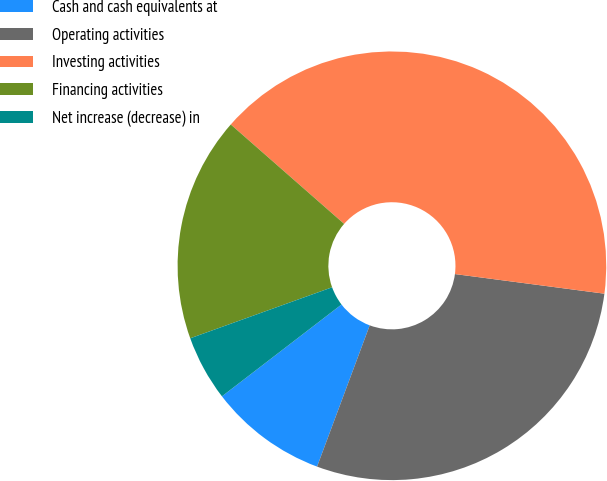Convert chart. <chart><loc_0><loc_0><loc_500><loc_500><pie_chart><fcel>Cash and cash equivalents at<fcel>Operating activities<fcel>Investing activities<fcel>Financing activities<fcel>Net increase (decrease) in<nl><fcel>8.9%<fcel>28.6%<fcel>40.62%<fcel>16.95%<fcel>4.93%<nl></chart> 